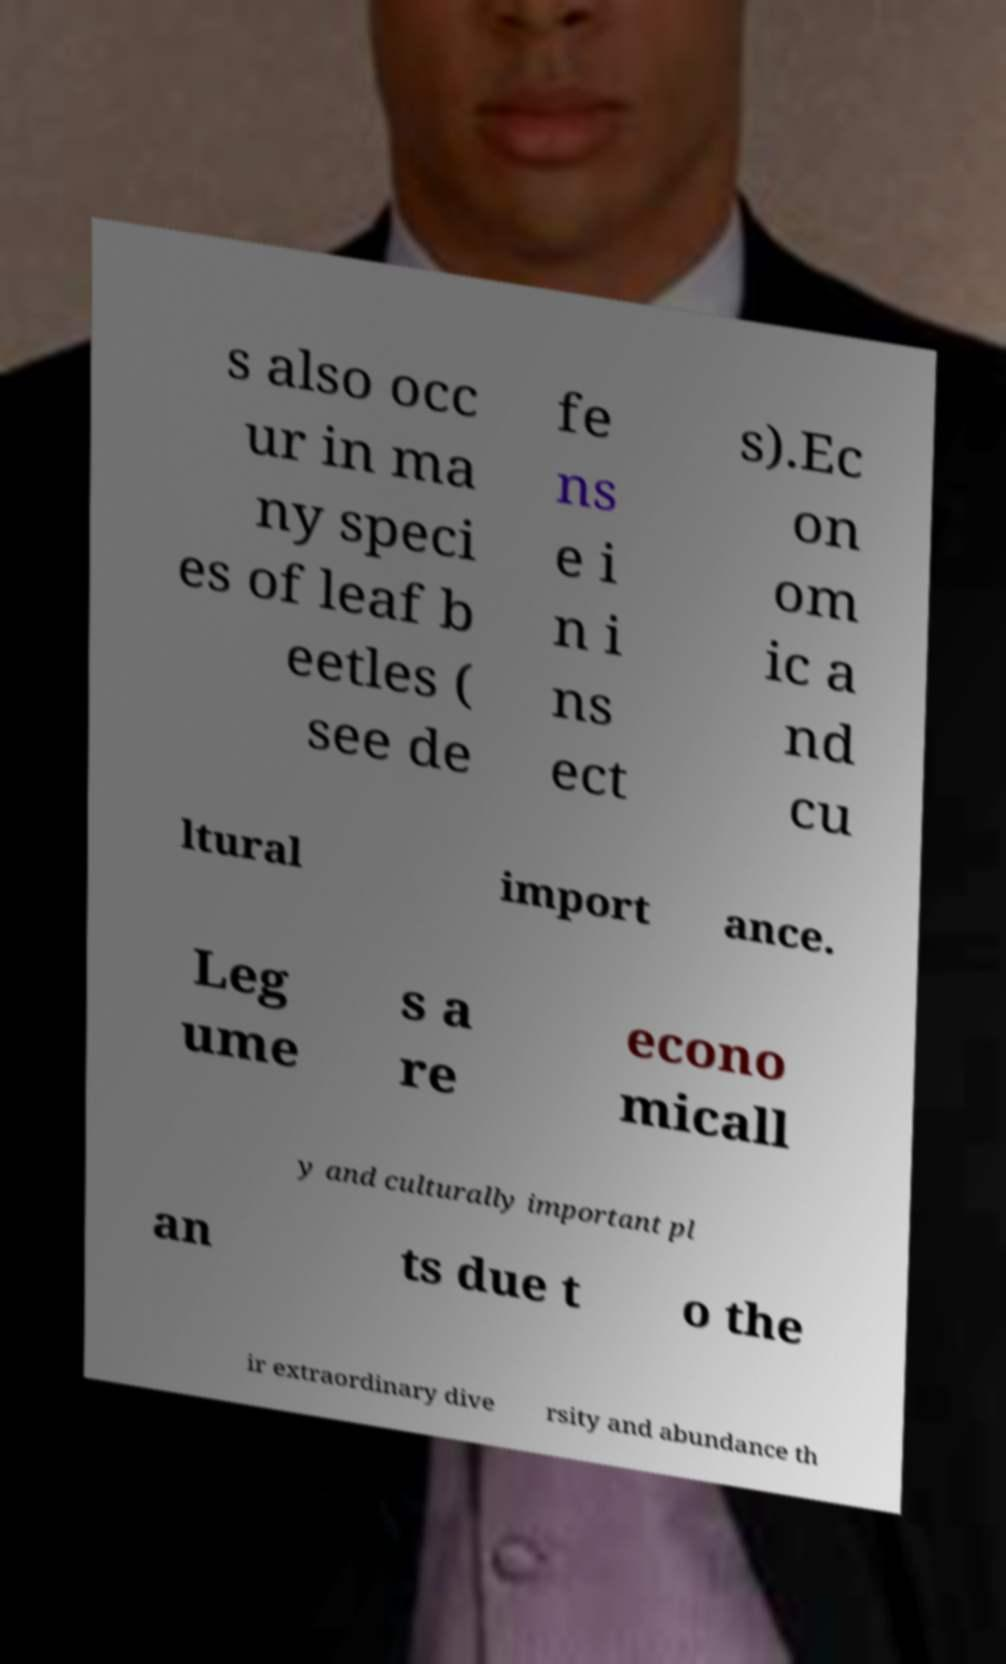Could you extract and type out the text from this image? s also occ ur in ma ny speci es of leaf b eetles ( see de fe ns e i n i ns ect s).Ec on om ic a nd cu ltural import ance. Leg ume s a re econo micall y and culturally important pl an ts due t o the ir extraordinary dive rsity and abundance th 